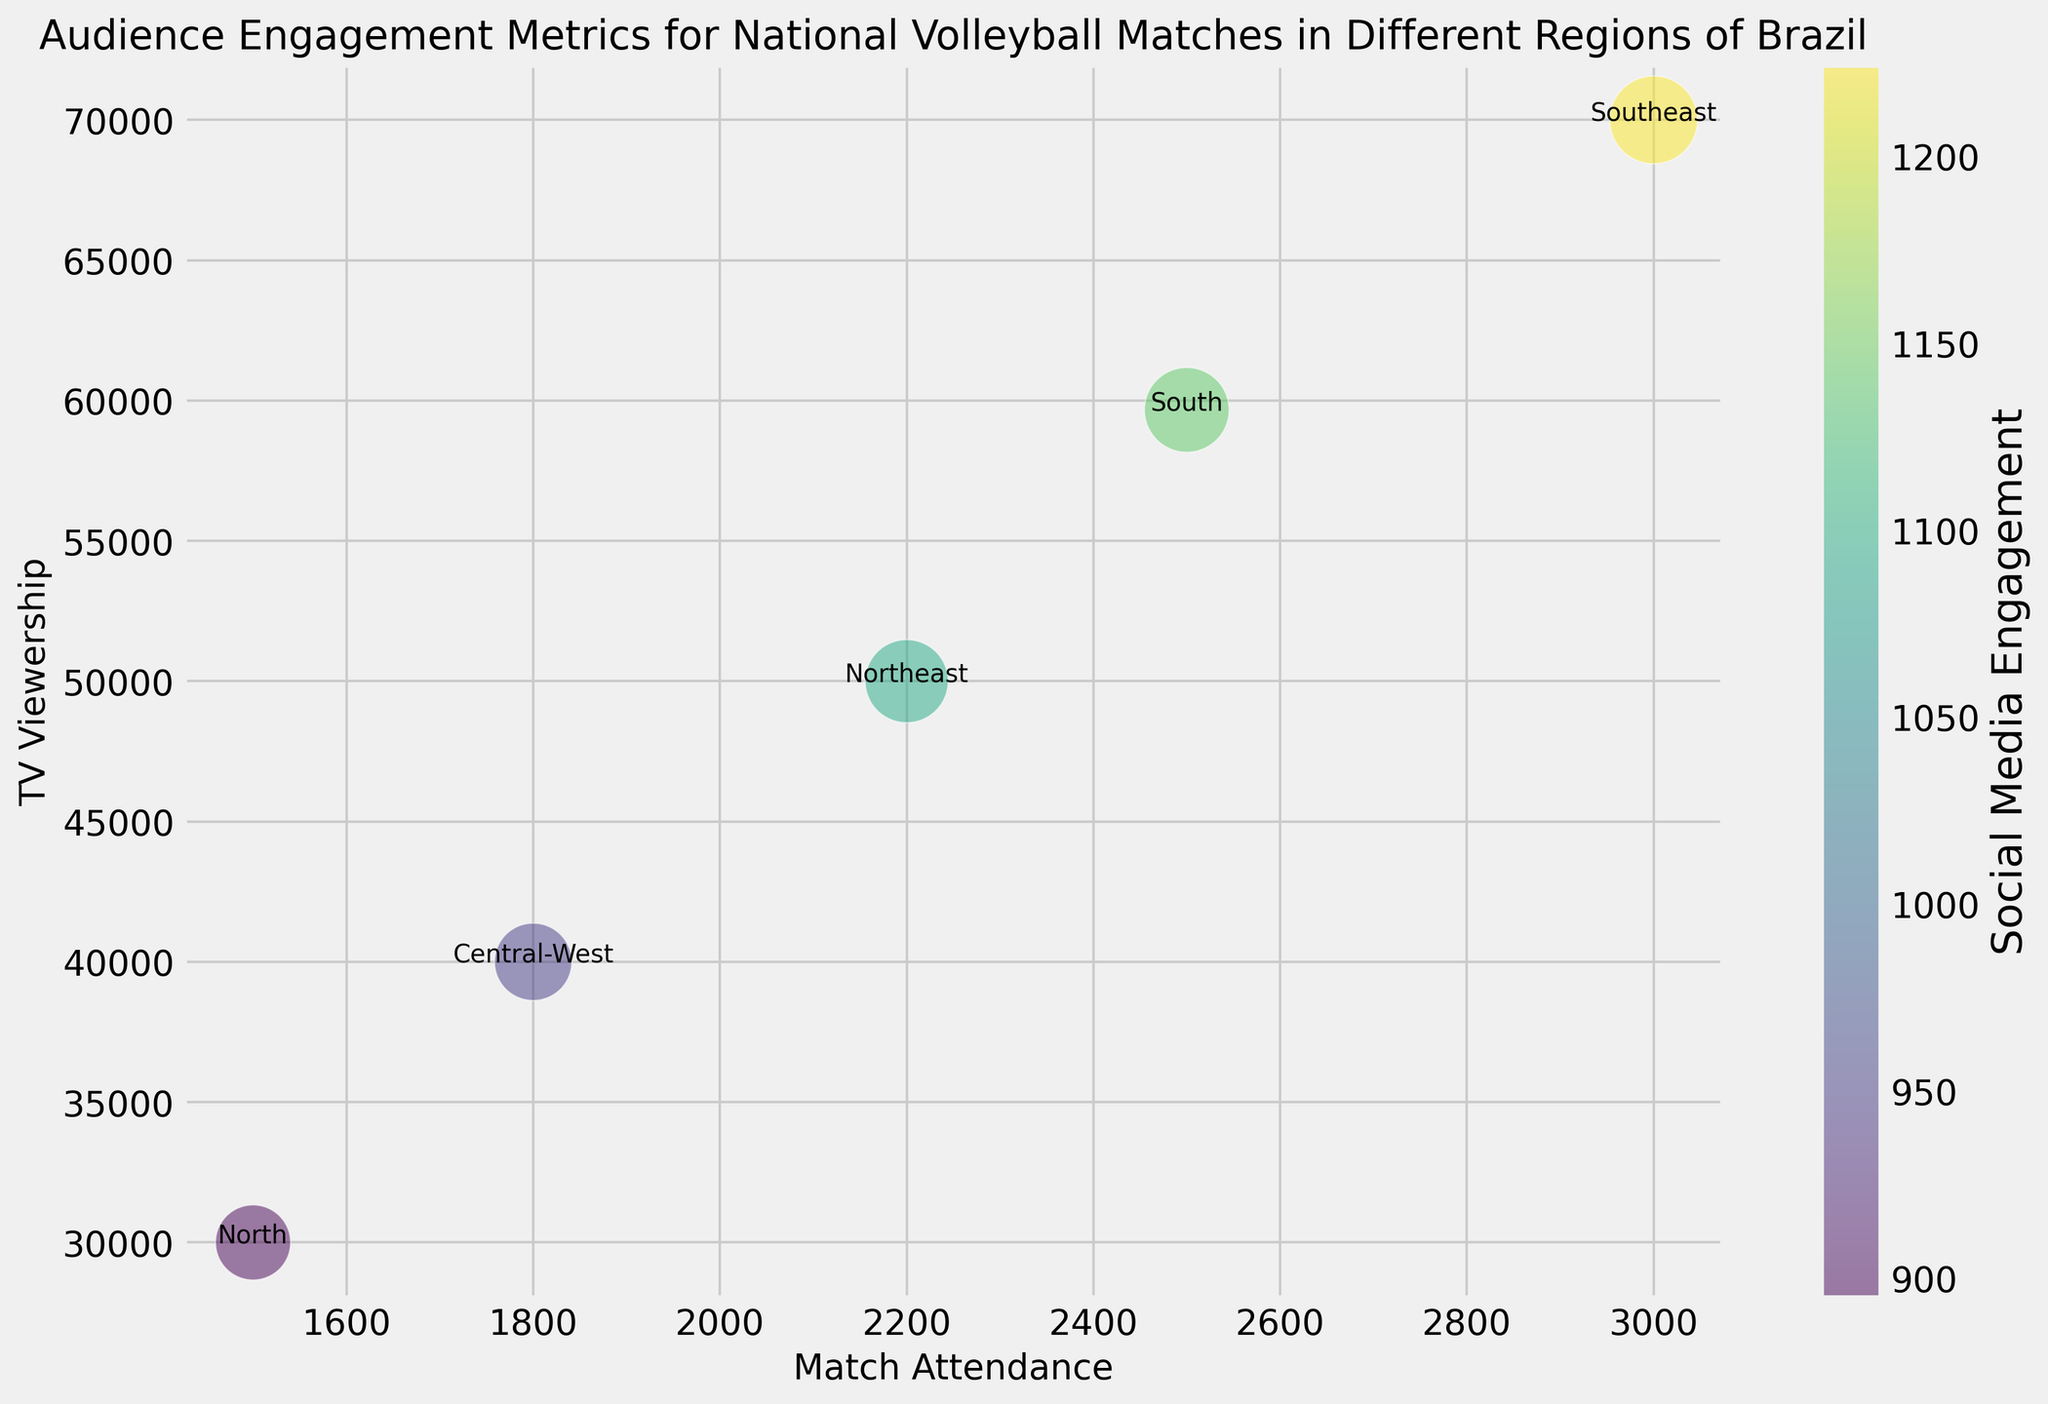Which region has the highest average match attendance? By looking at the scatter plot, find the region with the highest position on the x-axis. The Southeast region has the highest position on the x-axis, indicating the highest average match attendance.
Answer: Southeast Which region has the lowest TV viewership? By evaluating the position of the points on the y-axis, identify the region with the lowest position. The North region has the lowest position on the y-axis, showing the lowest TV viewership.
Answer: North Which region has the highest average social media engagement? The size of the bubbles represents social media engagement. Identify the region with the largest bubble. The Southeast region has the largest bubble, indicating the highest social media engagement.
Answer: Southeast How does the average TV viewership in the South region compare to the Northeast region? Compare the y-axis values of the South and Northeast regions. The South has a slightly higher average TV viewership compared to the Northeast.
Answer: South is higher Which region has both high match attendance and high TV viewership? Look for the region positioned highest on both the x-axis and y-axis. The Southeast region is positioned high on both axes, indicating high match attendance and TV viewership.
Answer: Southeast Does the Central-West region have higher social media engagement compared to the North region? Compare the bubble sizes of the Central-West and North regions. The Central-West region has slightly larger bubbles, indicating higher social media engagement.
Answer: Yes What is the difference in match attendance between the South and North regions? Measure the horizontal distance between the South and North bubbles. Subtract the North region's match attendance from the South's. The difference is calculated by 2500 - 1500 = 1000 (not necessarily exact numbers due to averaging).
Answer: 1000 Which region generally attracts more TV viewers compared to others? Identify the region with the highest vertical positions on the y-axis. The Southeast region consistently has the highest TV viewership when averaged.
Answer: Southeast Are there regions with similar levels of social media engagement? Compare the sizes of the bubbles to see if there are regions with similarly sized bubbles. The South and Northeast regions have closely sized bubbles, suggesting similar social media engagement.
Answer: South and Northeast What can you infer about the audience engagement in relation to match attendance and TV viewership? Higher match attendance and TV viewership generally correlate with higher social media engagement, as seen with the Southeast region. Regions with more in-person and TV audience tend to have more active social media engagement.
Answer: Higher engagement correlates 